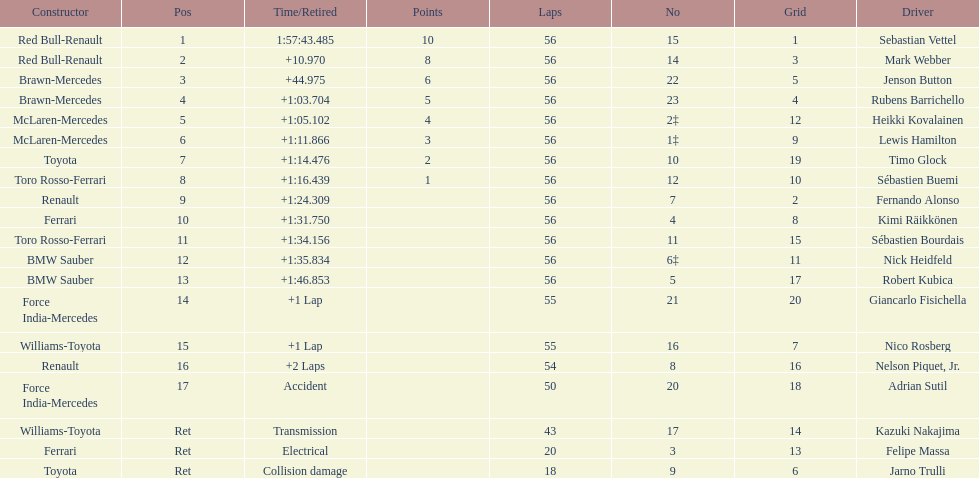What is the name of a driver that ferrari was not a constructor for? Sebastian Vettel. 